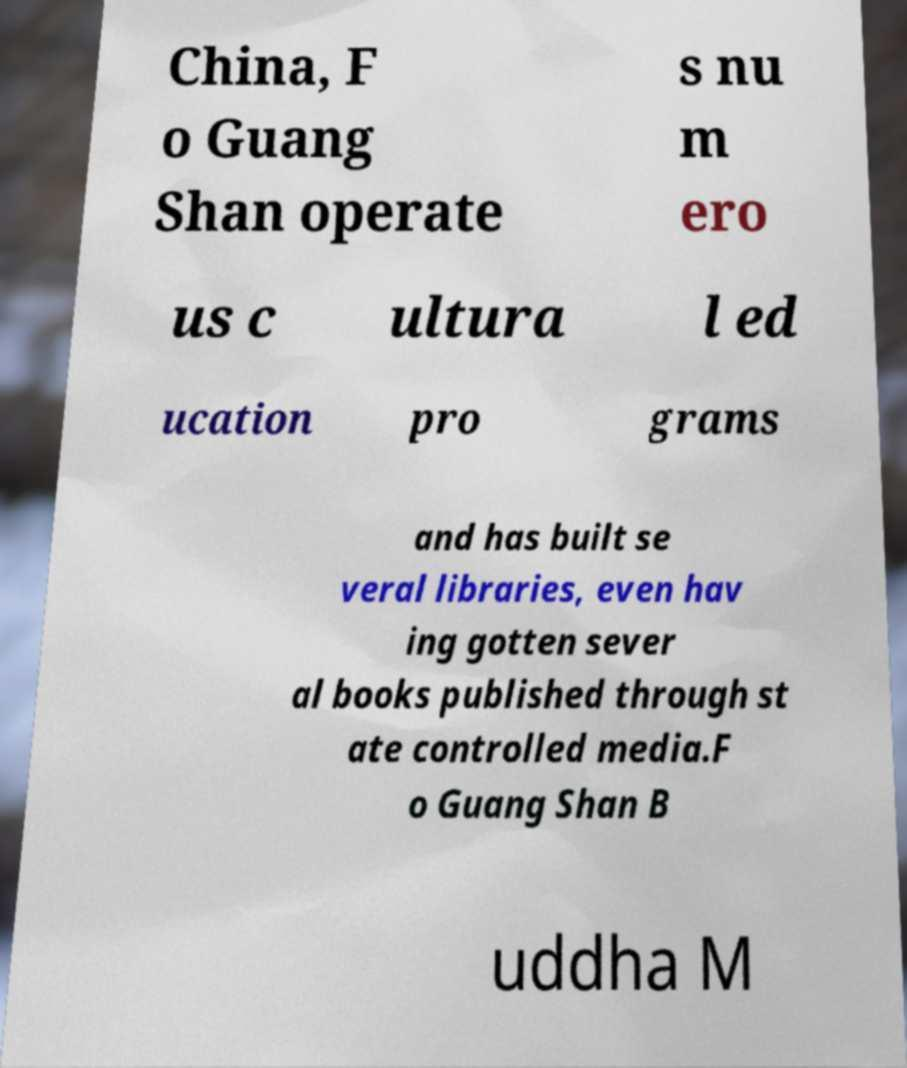I need the written content from this picture converted into text. Can you do that? China, F o Guang Shan operate s nu m ero us c ultura l ed ucation pro grams and has built se veral libraries, even hav ing gotten sever al books published through st ate controlled media.F o Guang Shan B uddha M 